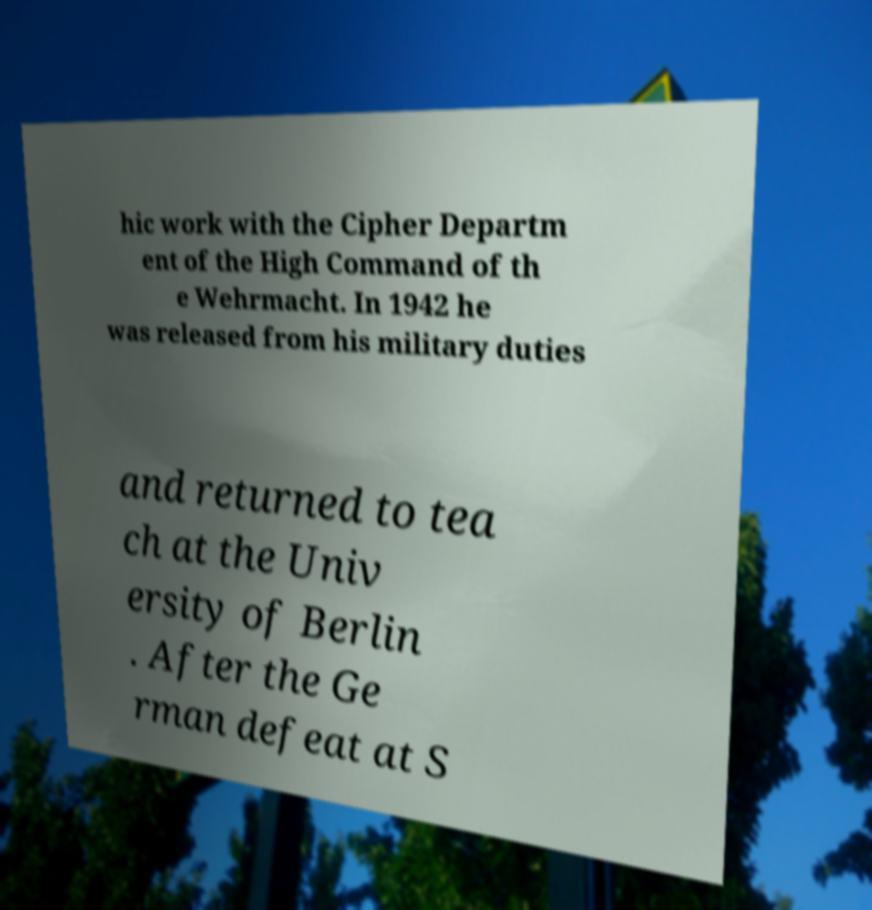I need the written content from this picture converted into text. Can you do that? hic work with the Cipher Departm ent of the High Command of th e Wehrmacht. In 1942 he was released from his military duties and returned to tea ch at the Univ ersity of Berlin . After the Ge rman defeat at S 